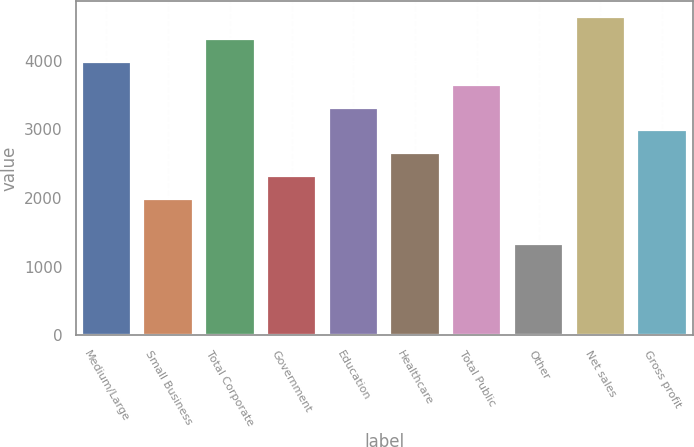<chart> <loc_0><loc_0><loc_500><loc_500><bar_chart><fcel>Medium/Large<fcel>Small Business<fcel>Total Corporate<fcel>Government<fcel>Education<fcel>Healthcare<fcel>Total Public<fcel>Other<fcel>Net sales<fcel>Gross profit<nl><fcel>3976.75<fcel>1988.41<fcel>4308.14<fcel>2319.8<fcel>3313.97<fcel>2651.19<fcel>3645.36<fcel>1325.63<fcel>4639.53<fcel>2982.58<nl></chart> 